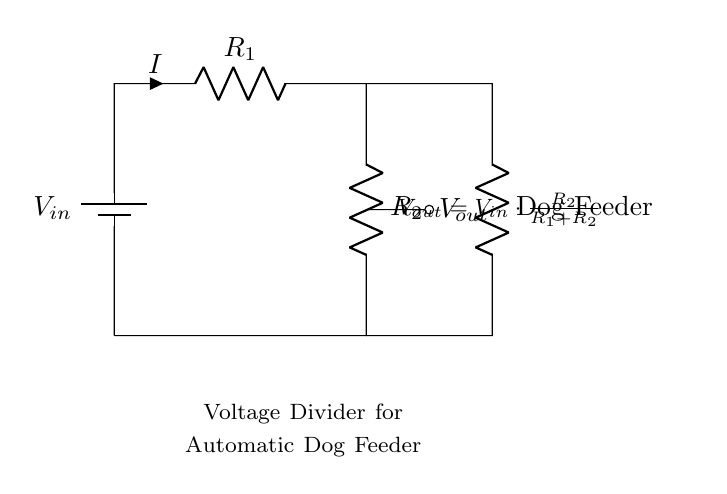What is the input voltage of the circuit? The input voltage is represented by the label \( V_{in} \) on the battery, which indicates the source voltage for the voltage divider.
Answer: V_in What is the function of the resistors in this circuit? The resistors \( R_1 \) and \( R_2 \) form a voltage divider that controls the output voltage \( V_{out} \) supplied to the dog feeder.
Answer: Voltage regulation What is the output voltage related to the input voltage? The output voltage \( V_{out} \) is given by the formula \( V_{out} = V_{in} \cdot \frac{R_2}{R_1 + R_2} \), demonstrating that \( V_{out} \) is proportional to \( V_{in} \) based on the resistor values.
Answer: Proportionality What are the resistors labeled in the circuit? The resistors are labeled as \( R_1 \) and \( R_2 \), which allows for easy identification of their roles in the voltage divider configuration.
Answer: R_1 and R_2 What happens to the current as it passes through the resistors? The current \( I \) is the same through \( R_1 \) and \( R_2 \) because they are in series, meaning that it remains constant throughout this portion of the circuit.
Answer: Constant current What is the load connected to the output? The load connected to the output is labeled as "Dog Feeder," indicating that this is the component receiving the regulated power supply from the voltage divider.
Answer: Dog Feeder How do the resistor values affect the output voltage? The output voltage \( V_{out} \) is influenced by the ratio of \( R_2 \) to the total resistance \( R_1 + R_2 \); larger \( R_2 \) values increase \( V_{out} \) while smaller \( R_1 \) values decrease it.
Answer: Affects proportionally 